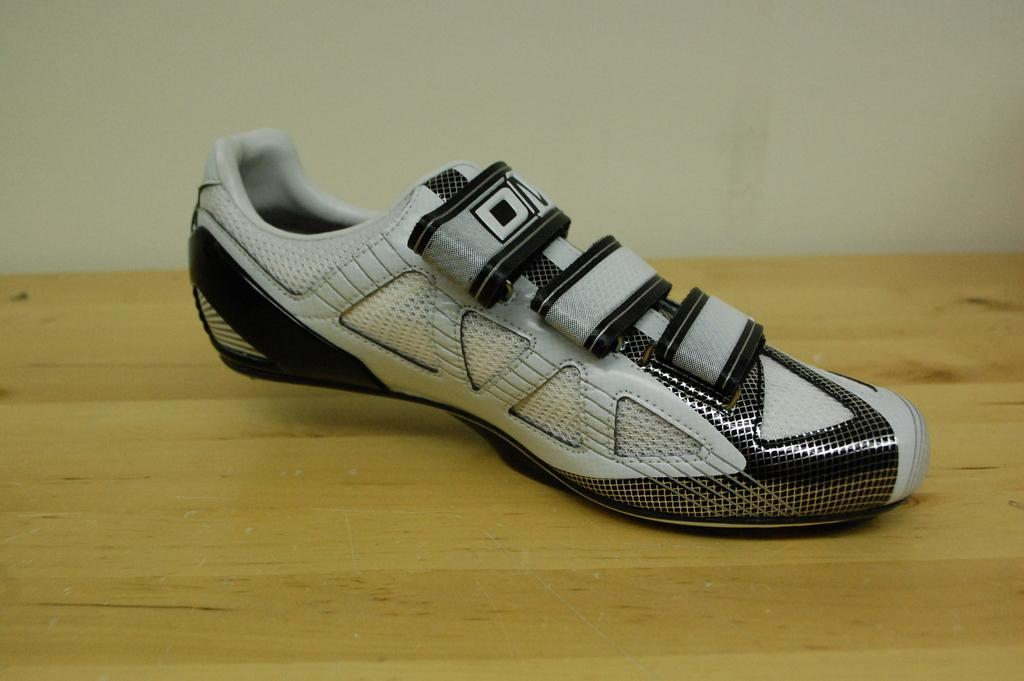What is the main subject of the image? The main subject of the image is a shoe. Where is the shoe located in the image? The shoe is placed on a wooden object, possibly a table. What can be seen in the background of the image? There is a wall in the background of the image. Can you tell me how many mittens are being used to help the child on the playground in the image? There is no child, mitten, or playground present in the image; it only features a shoe placed on a wooden object. 